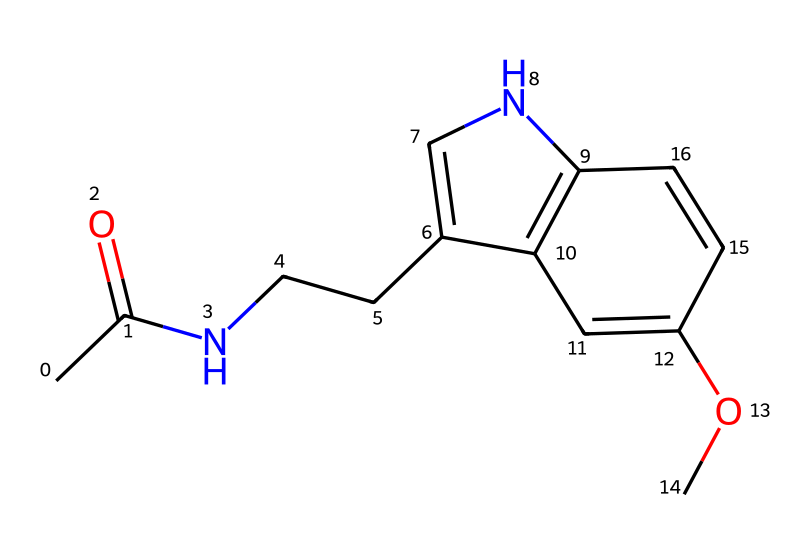What is the molecular formula of melatonin? To determine the molecular formula, we analyze the SMILES representation, which indicates the number of each atom present in the molecule: carbon (C), hydrogen (H), nitrogen (N), and oxygen (O). Counting the atoms in the SMILES gives us C13H16N2O2.
Answer: C13H16N2O2 How many rings are present in the structure? By examining the SMILES and visualizing the structure, we identify that there are two distinct fused aromatic rings. The connections suggest a bicyclic system.
Answer: 2 What functional groups are present in melatonin? The SMILES notation reveals the presence of an amide group (indicated by the C(=O)N information) and a methoxy group (–OCH3), which are characteristic when parsing the structure.
Answer: amide and methoxy What does the nitrogen atom in the structure indicate? The presence of nitrogen generally relates to the classification of the compound, and in this case, it indicates that melatonin is an indoleamine. The nitrogen's placement in a cyclic structure also suggests its involvement in the aromatic system.
Answer: indoleamine What is the significance of the methoxy group in melatonin? The methoxy group (–OCH3) contributes to the electron-donating properties of the molecule and may affect its solubility and interactions with receptors, which is vital for its biological activity as a hormone.
Answer: enhances solubility How does the structure of melatonin relate to its function in the body? The specific arrangement of rings and functional groups in melatonin allows it to bind effectively to melatonin receptors, regulating sleep-wake cycles. The structure is tailored for biological interactions pertinent to its role as a hormone.
Answer: regulates sleep-wake cycles What type of molecule is melatonin classified as? Analyzing its structure and function, melatonin is categorized as a hormone since it is produced in the pineal gland and regulates physiological processes, particularly pertaining to sleep.
Answer: hormone 